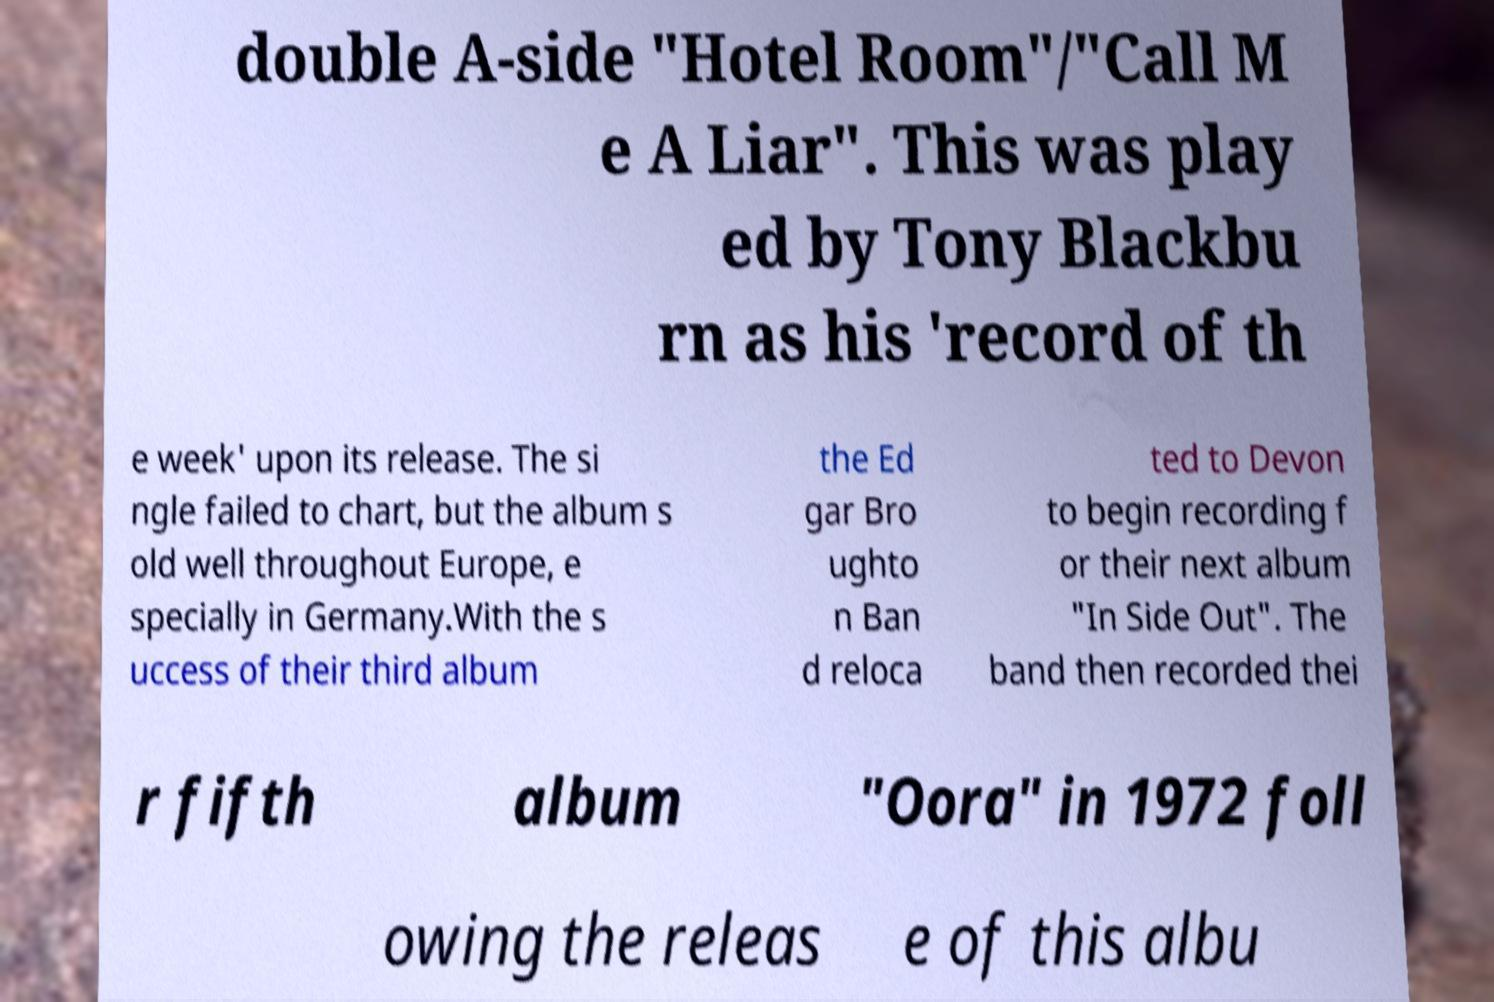There's text embedded in this image that I need extracted. Can you transcribe it verbatim? double A-side "Hotel Room"/"Call M e A Liar". This was play ed by Tony Blackbu rn as his 'record of th e week' upon its release. The si ngle failed to chart, but the album s old well throughout Europe, e specially in Germany.With the s uccess of their third album the Ed gar Bro ughto n Ban d reloca ted to Devon to begin recording f or their next album "In Side Out". The band then recorded thei r fifth album "Oora" in 1972 foll owing the releas e of this albu 